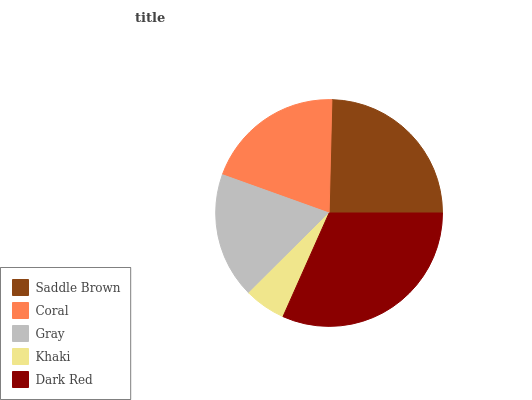Is Khaki the minimum?
Answer yes or no. Yes. Is Dark Red the maximum?
Answer yes or no. Yes. Is Coral the minimum?
Answer yes or no. No. Is Coral the maximum?
Answer yes or no. No. Is Saddle Brown greater than Coral?
Answer yes or no. Yes. Is Coral less than Saddle Brown?
Answer yes or no. Yes. Is Coral greater than Saddle Brown?
Answer yes or no. No. Is Saddle Brown less than Coral?
Answer yes or no. No. Is Coral the high median?
Answer yes or no. Yes. Is Coral the low median?
Answer yes or no. Yes. Is Khaki the high median?
Answer yes or no. No. Is Dark Red the low median?
Answer yes or no. No. 